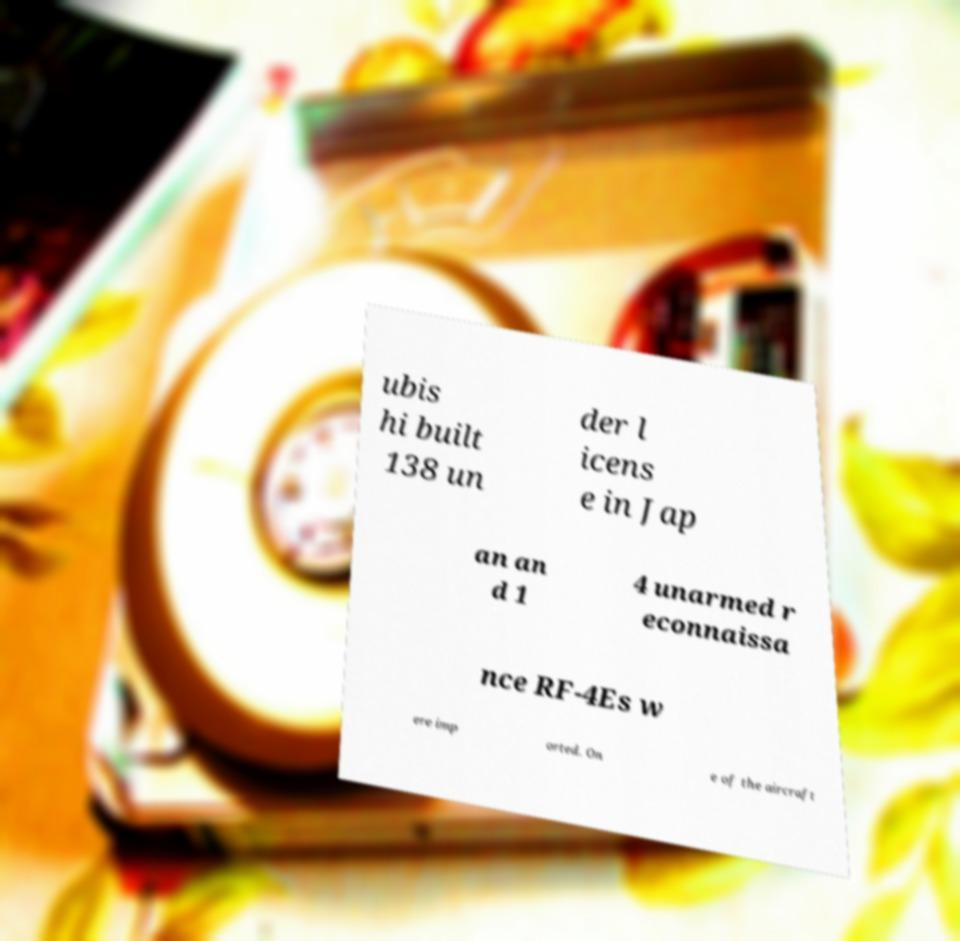Please identify and transcribe the text found in this image. ubis hi built 138 un der l icens e in Jap an an d 1 4 unarmed r econnaissa nce RF-4Es w ere imp orted. On e of the aircraft 